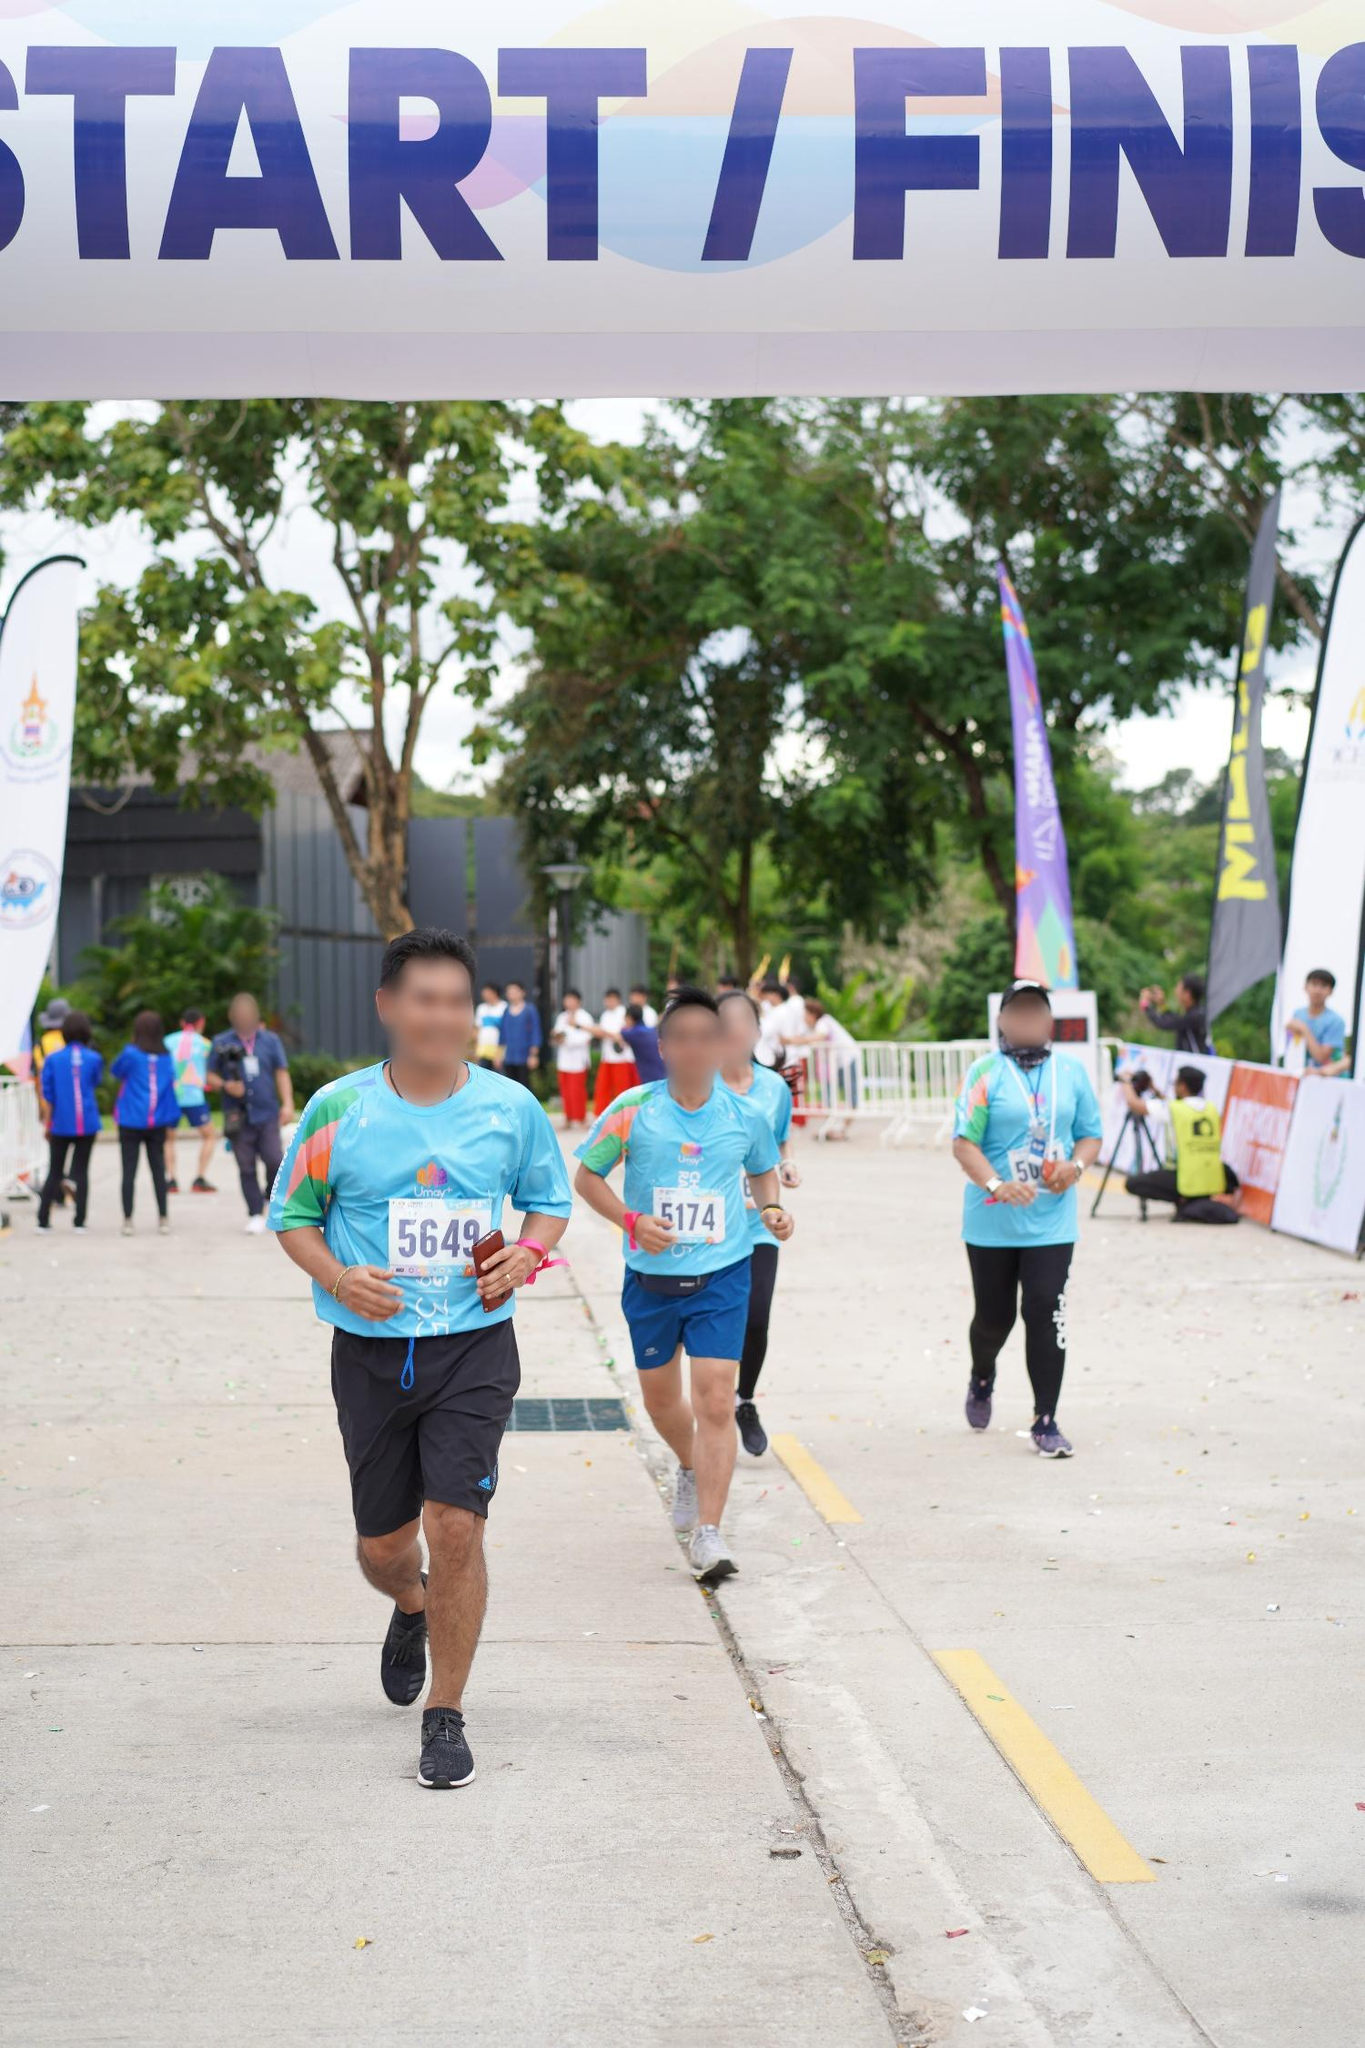What emotions do you think the runners are experiencing as they cross the line? The runners are likely experiencing a mix of emotions. The runner in the foreground appears focused and determined, perhaps a mix of relief and joy as he nears the finish line. They might also feel exhaustion from their effort but jubilant upon completing the race. The crowd's presence, the serene background, and the supportive environment contribute to a sense of accomplishment and community celebration. 